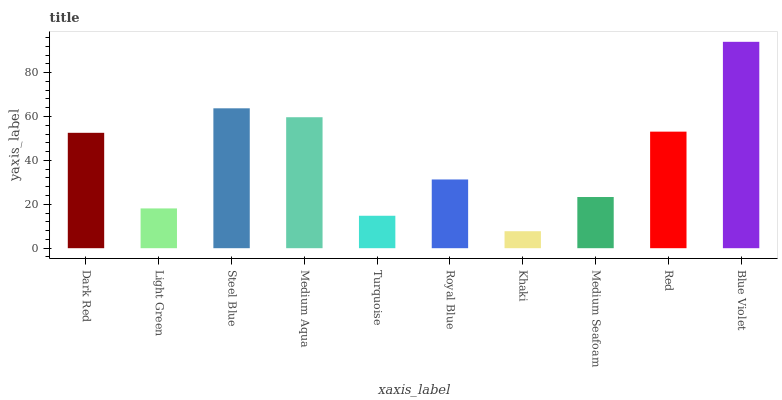Is Khaki the minimum?
Answer yes or no. Yes. Is Blue Violet the maximum?
Answer yes or no. Yes. Is Light Green the minimum?
Answer yes or no. No. Is Light Green the maximum?
Answer yes or no. No. Is Dark Red greater than Light Green?
Answer yes or no. Yes. Is Light Green less than Dark Red?
Answer yes or no. Yes. Is Light Green greater than Dark Red?
Answer yes or no. No. Is Dark Red less than Light Green?
Answer yes or no. No. Is Dark Red the high median?
Answer yes or no. Yes. Is Royal Blue the low median?
Answer yes or no. Yes. Is Medium Seafoam the high median?
Answer yes or no. No. Is Turquoise the low median?
Answer yes or no. No. 